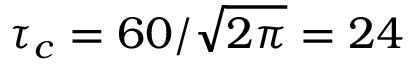Convert formula to latex. <formula><loc_0><loc_0><loc_500><loc_500>\tau _ { c } = 6 0 / \sqrt { 2 \pi } = 2 4</formula> 